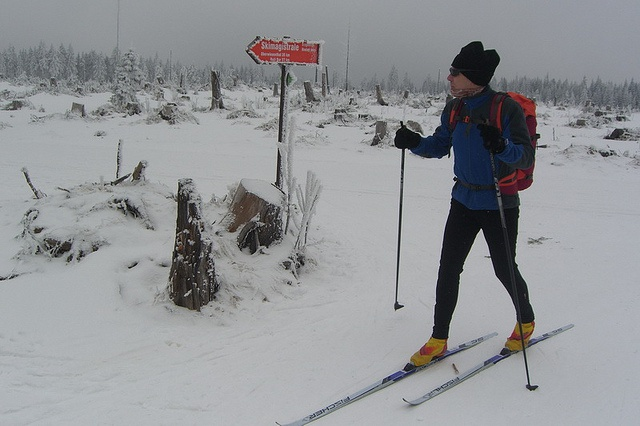Describe the objects in this image and their specific colors. I can see people in darkgray, black, navy, maroon, and olive tones, skis in darkgray, gray, and black tones, and backpack in darkgray, maroon, black, brown, and gray tones in this image. 